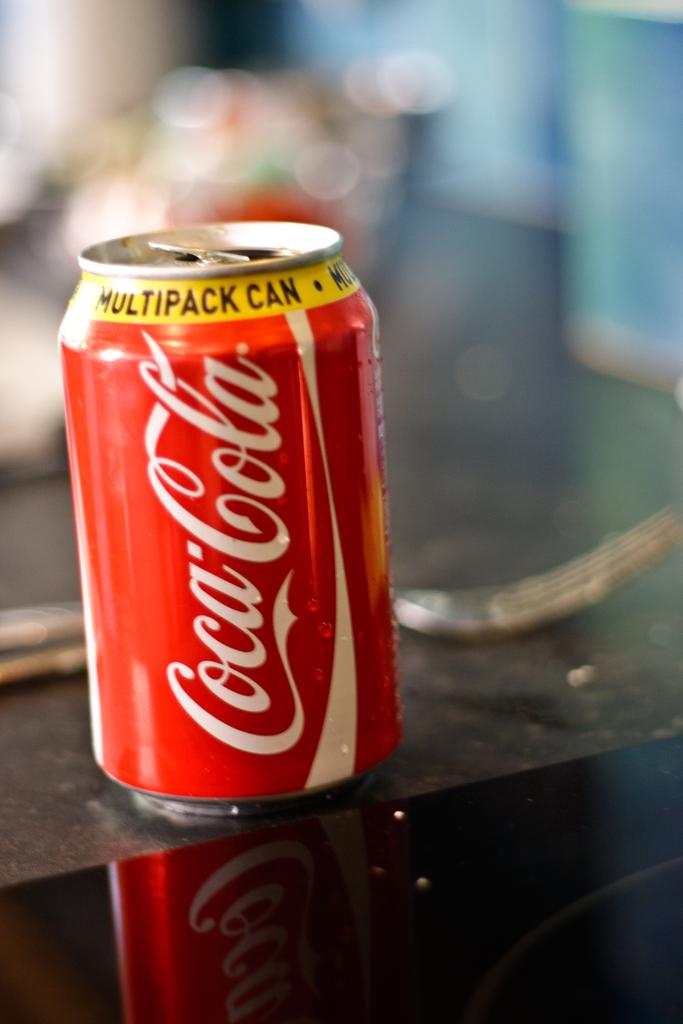<image>
Render a clear and concise summary of the photo. A Coca Cola can has a yellow band on it reading Multipack Can. 